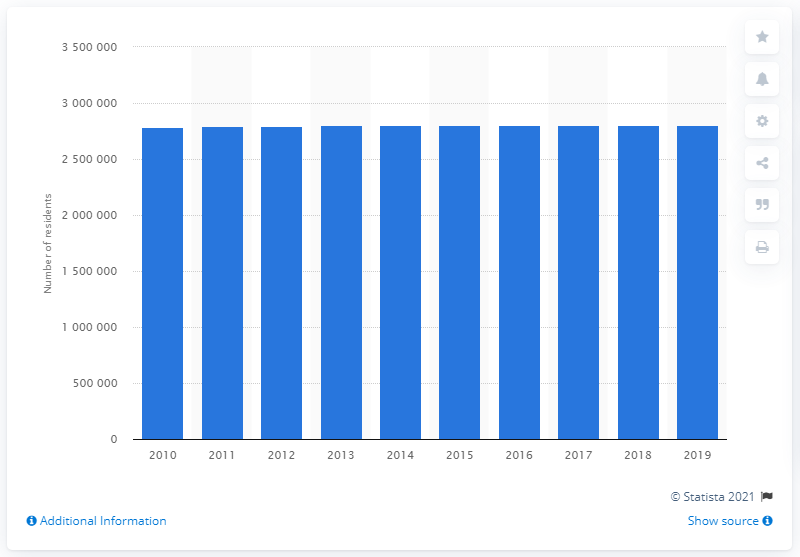Indicate a few pertinent items in this graphic. In 2019, the population of the St. Louis metropolitan area was approximately 2,789,989 people. 